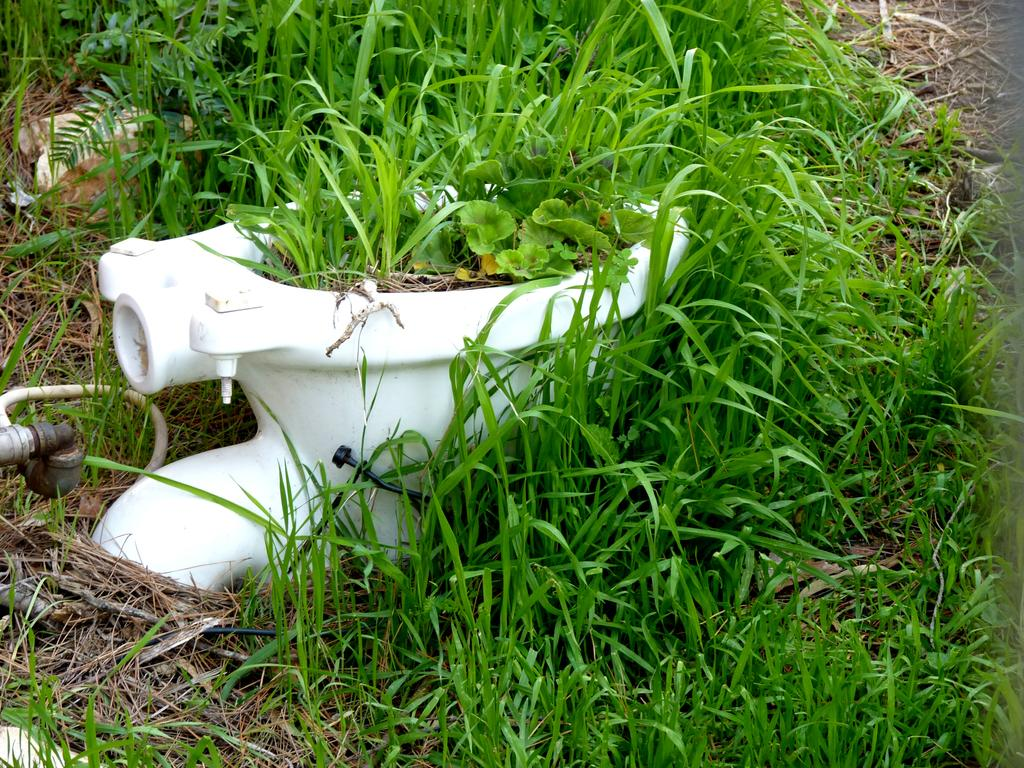What object is the main focus of the image? The main object in the image is a toilet seat. What color is the toilet seat? The toilet seat is white in color. Where is the toilet seat located in relation to the grass? The toilet seat is placed near a grass surface. What is unique about the grass in this image? Grass is grown on the toilet seat. How many cans of paint are needed to cover the grass on the toilet seat? There is no information about painting the grass on the toilet seat, and therefore, we cannot determine the number of cans of paint needed. 